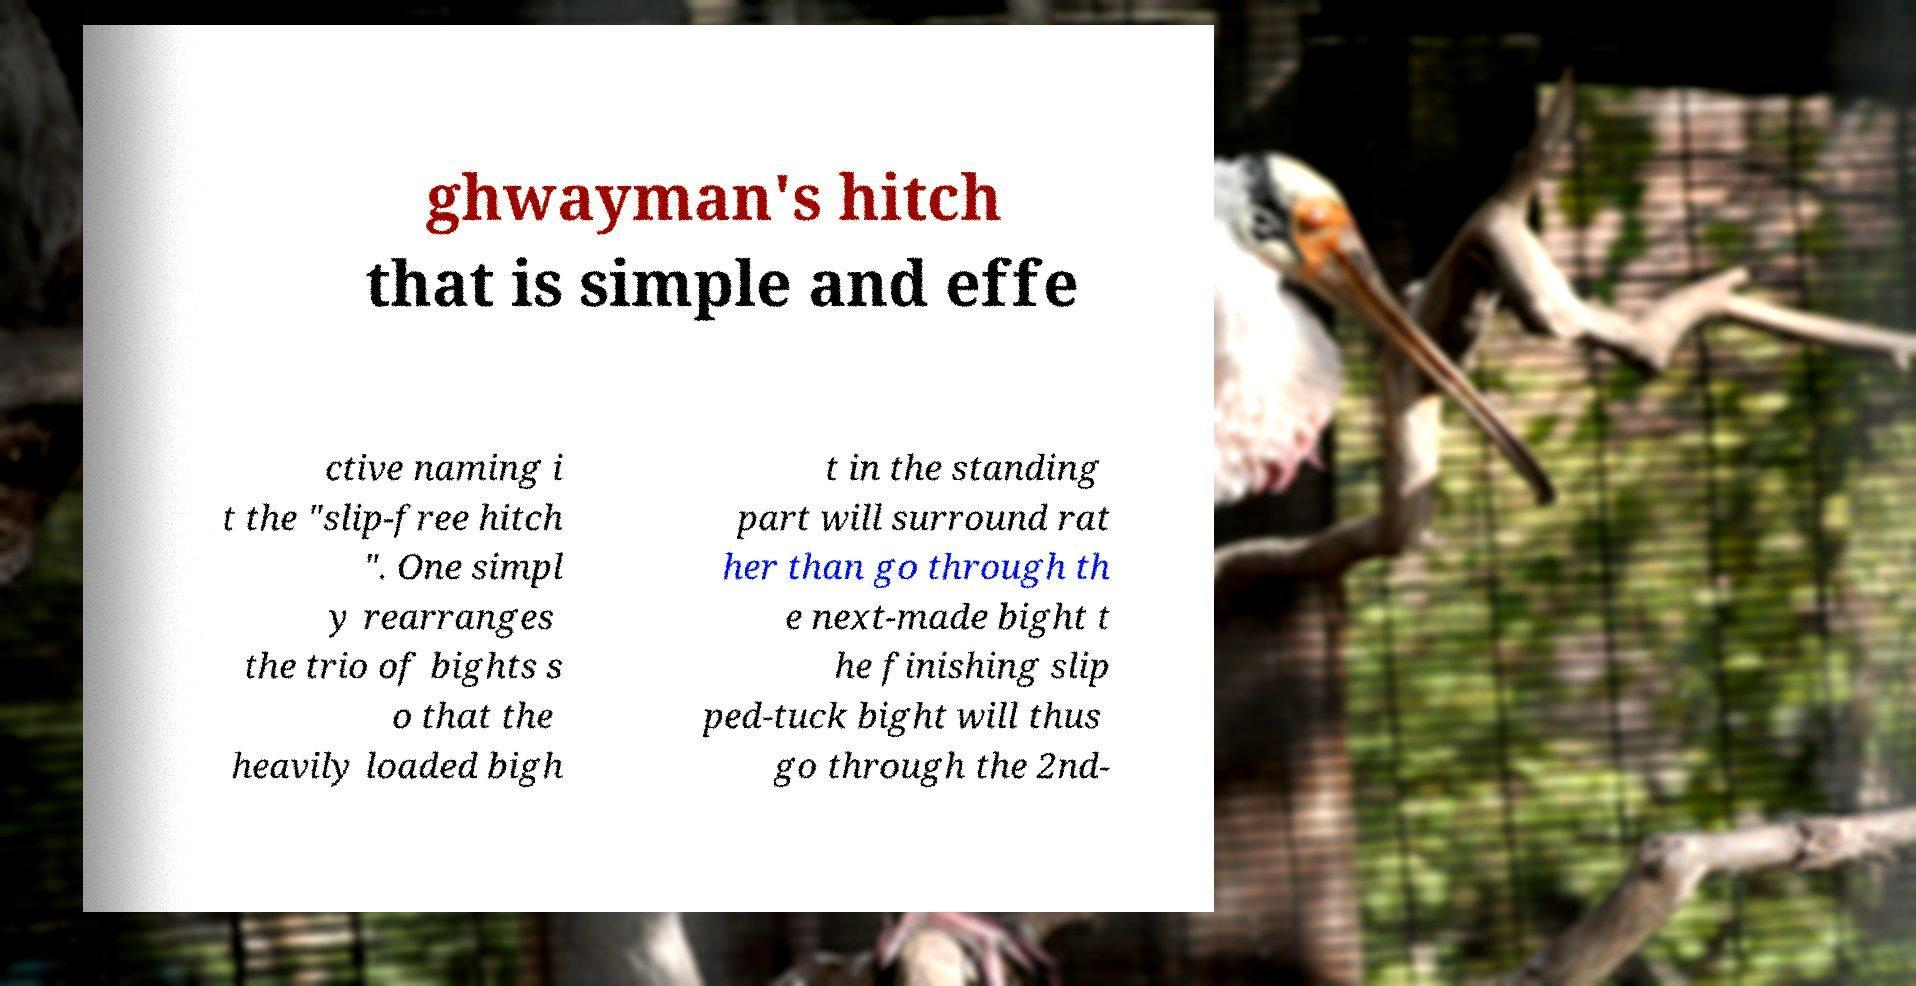Could you extract and type out the text from this image? ghwayman's hitch that is simple and effe ctive naming i t the "slip-free hitch ". One simpl y rearranges the trio of bights s o that the heavily loaded bigh t in the standing part will surround rat her than go through th e next-made bight t he finishing slip ped-tuck bight will thus go through the 2nd- 